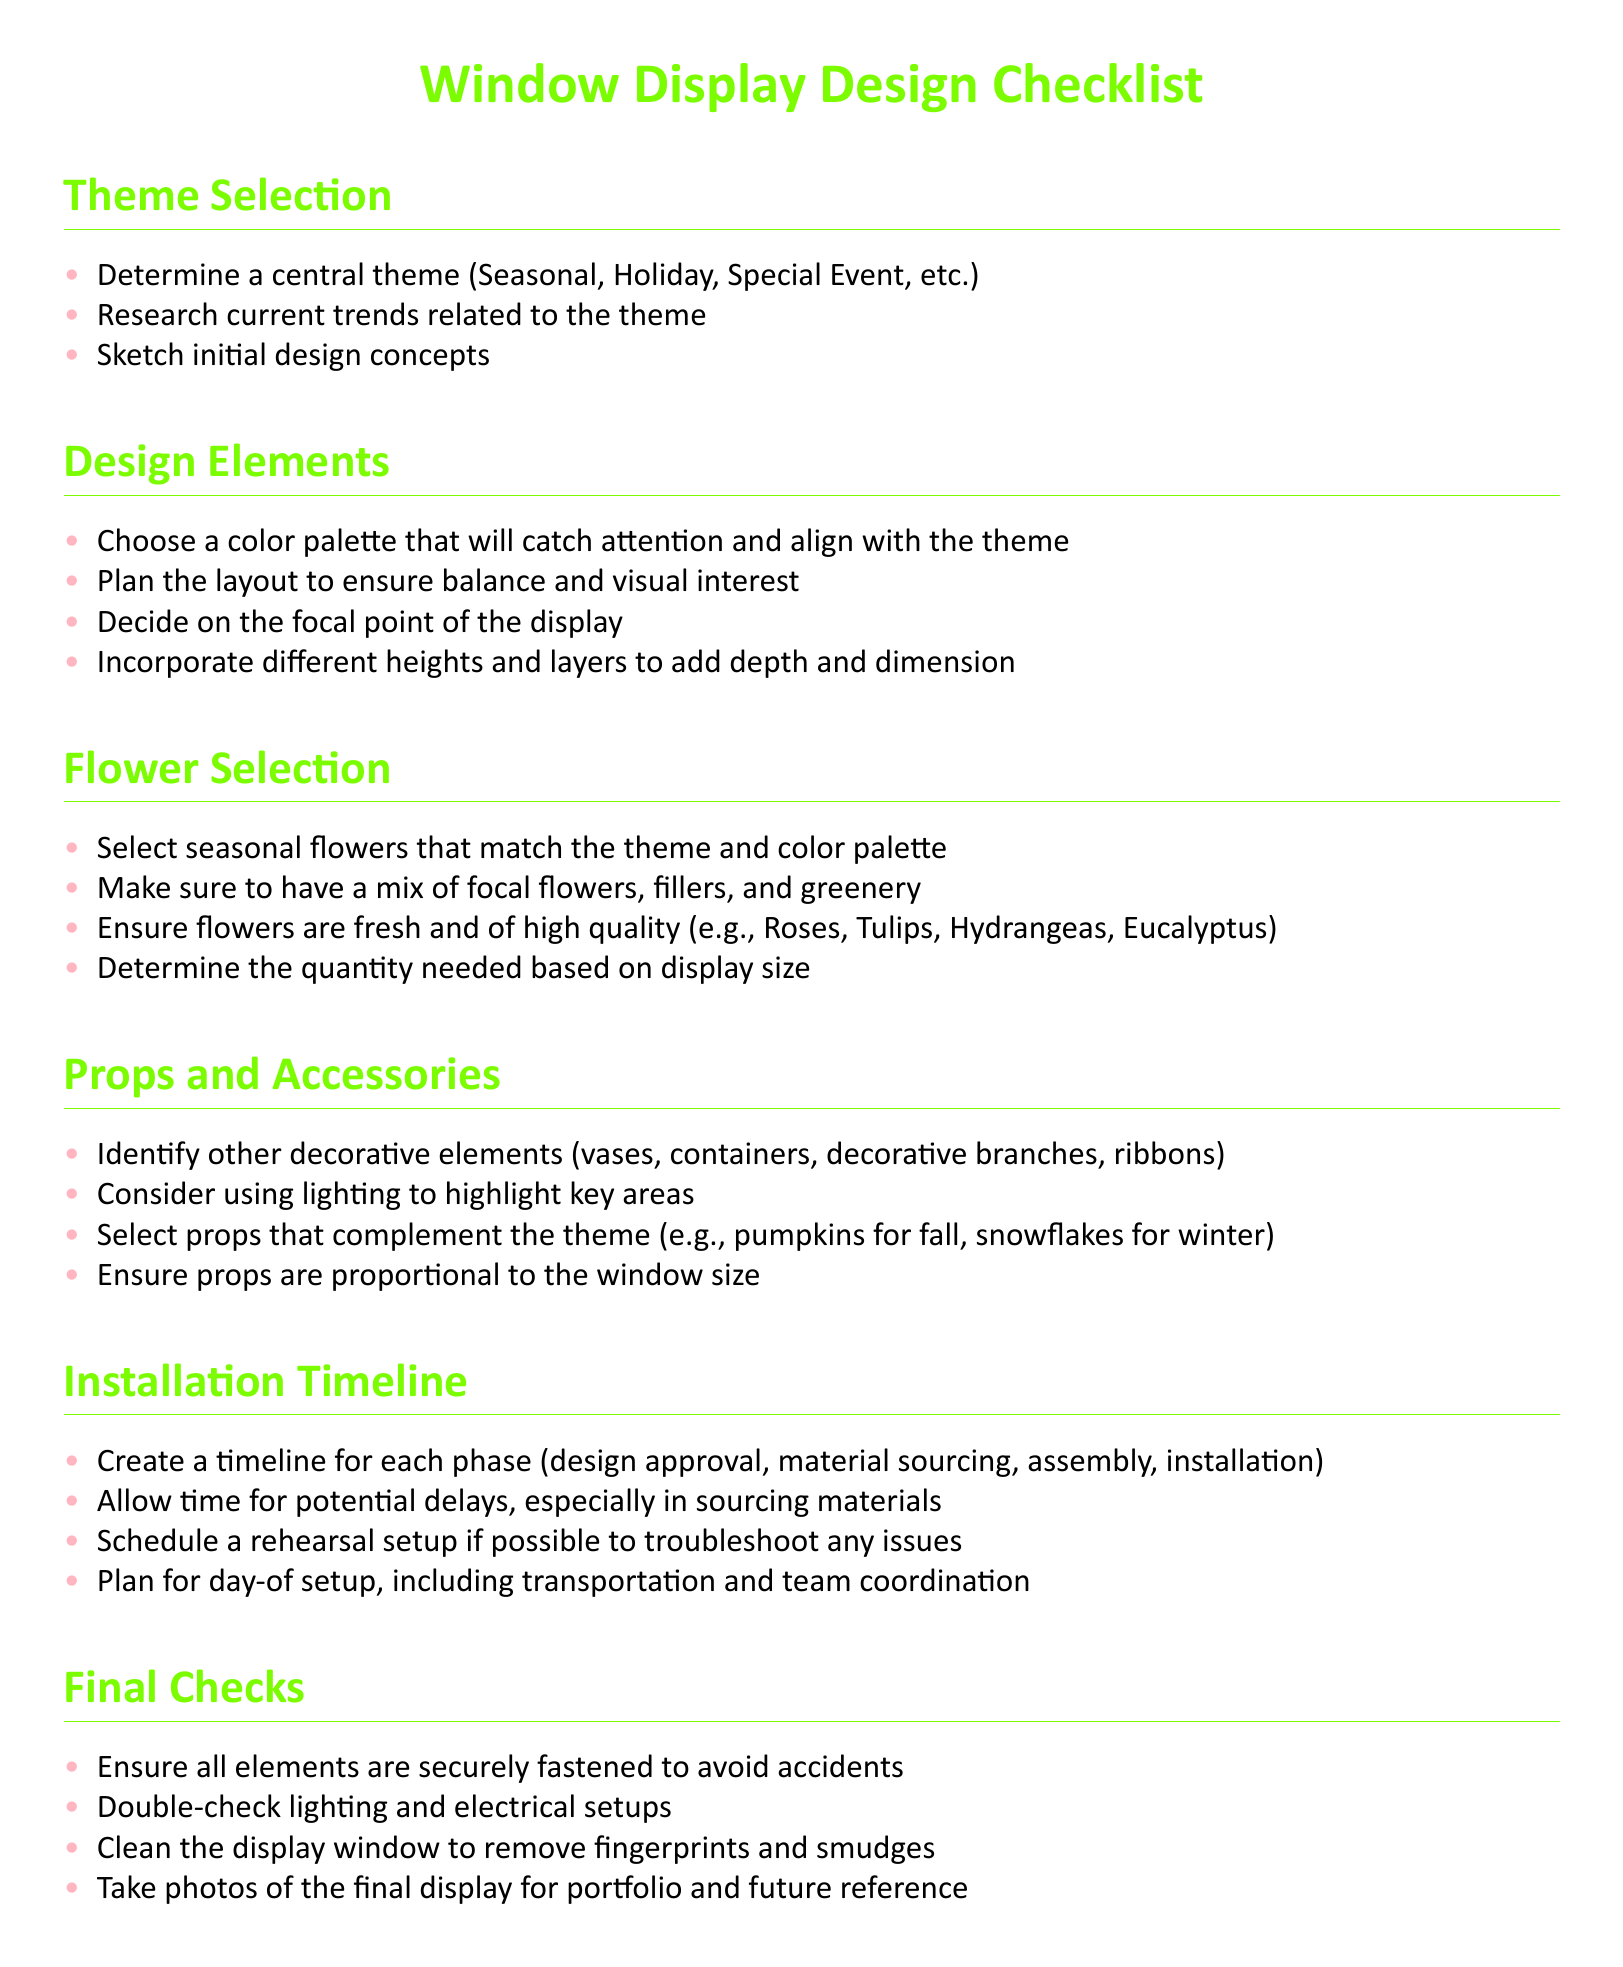What are the themes suggested for window displays? The document lists several themes such as Seasonal, Holiday, and Special Event.
Answer: Seasonal, Holiday, Special Event Which flowers are recommended for high quality? The checklist mentions specific high-quality flowers including Roses, Tulips, Hydrangeas, and Eucalyptus.
Answer: Roses, Tulips, Hydrangeas, Eucalyptus How many elements are suggested in the Design Elements section? The Design Elements section contains four items related to creating a visually appealing layout for the display.
Answer: Four What accessories should be considered for the window display? The document advises identifying decorative elements such as vases, containers, and decorative branches as props.
Answer: Vases, containers, decorative branches What is the first step in the Installation Timeline? The installation timeline begins with creating a timeline for different phases including design approval.
Answer: Create a timeline for each phase What is the purpose of the Final Checks section? The Final Checks section ensures safety and quality of the display by verifying that all elements are properly secured.
Answer: Ensure all elements are securely fastened What is included in the Flower Selection section? The Flower Selection section outlines key considerations for selecting flowers, including seasonal relevance and mix type.
Answer: Seasonal flowers that match the theme What color palette is recommended? The checklist suggests choosing a color palette that captures attention and aligns with the selected theme.
Answer: Color palette that will catch attention Are lighting considerations mentioned in the document? Yes, the checklist mentions using lighting to highlight key areas within the window display.
Answer: Yes 